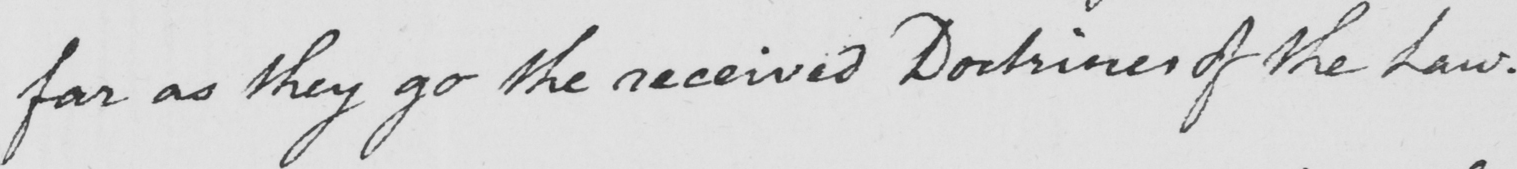Transcribe the text shown in this historical manuscript line. far as they go the received Doctrines of the Law . 